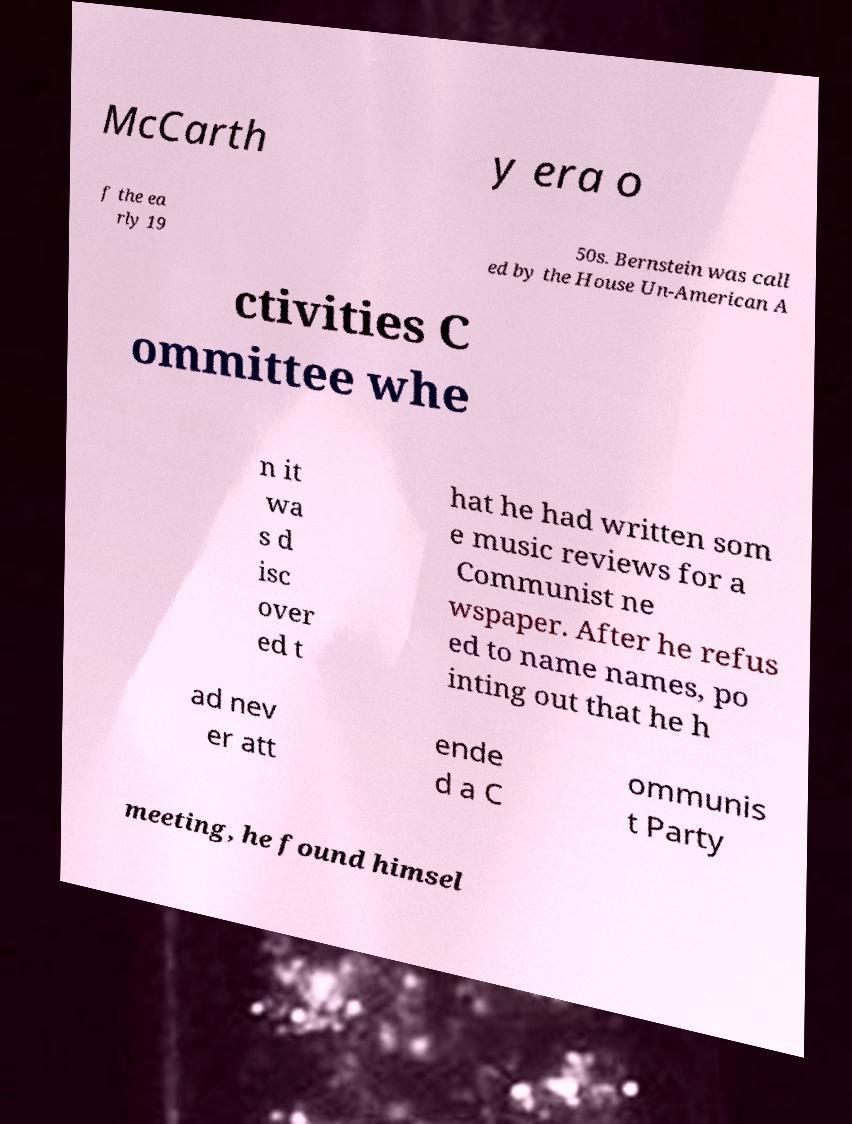There's text embedded in this image that I need extracted. Can you transcribe it verbatim? McCarth y era o f the ea rly 19 50s. Bernstein was call ed by the House Un-American A ctivities C ommittee whe n it wa s d isc over ed t hat he had written som e music reviews for a Communist ne wspaper. After he refus ed to name names, po inting out that he h ad nev er att ende d a C ommunis t Party meeting, he found himsel 